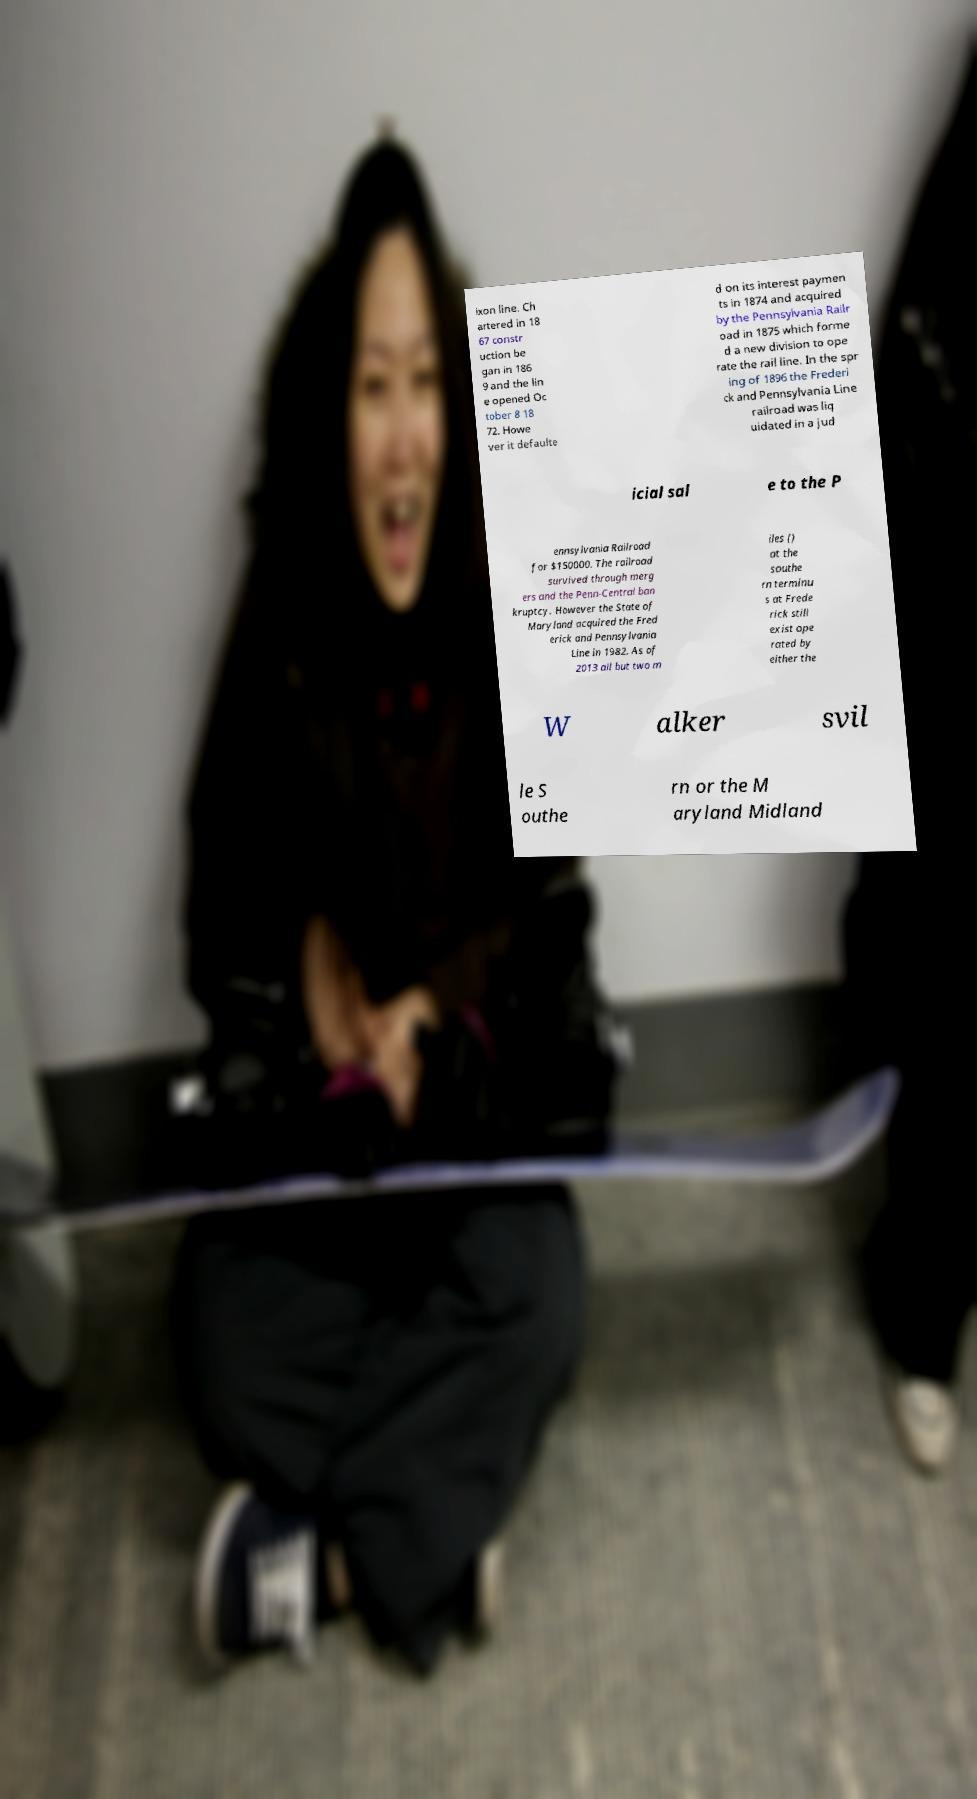Can you read and provide the text displayed in the image?This photo seems to have some interesting text. Can you extract and type it out for me? ixon line. Ch artered in 18 67 constr uction be gan in 186 9 and the lin e opened Oc tober 8 18 72. Howe ver it defaulte d on its interest paymen ts in 1874 and acquired by the Pennsylvania Railr oad in 1875 which forme d a new division to ope rate the rail line. In the spr ing of 1896 the Frederi ck and Pennsylvania Line railroad was liq uidated in a jud icial sal e to the P ennsylvania Railroad for $150000. The railroad survived through merg ers and the Penn-Central ban kruptcy. However the State of Maryland acquired the Fred erick and Pennsylvania Line in 1982. As of 2013 all but two m iles () at the southe rn terminu s at Frede rick still exist ope rated by either the W alker svil le S outhe rn or the M aryland Midland 